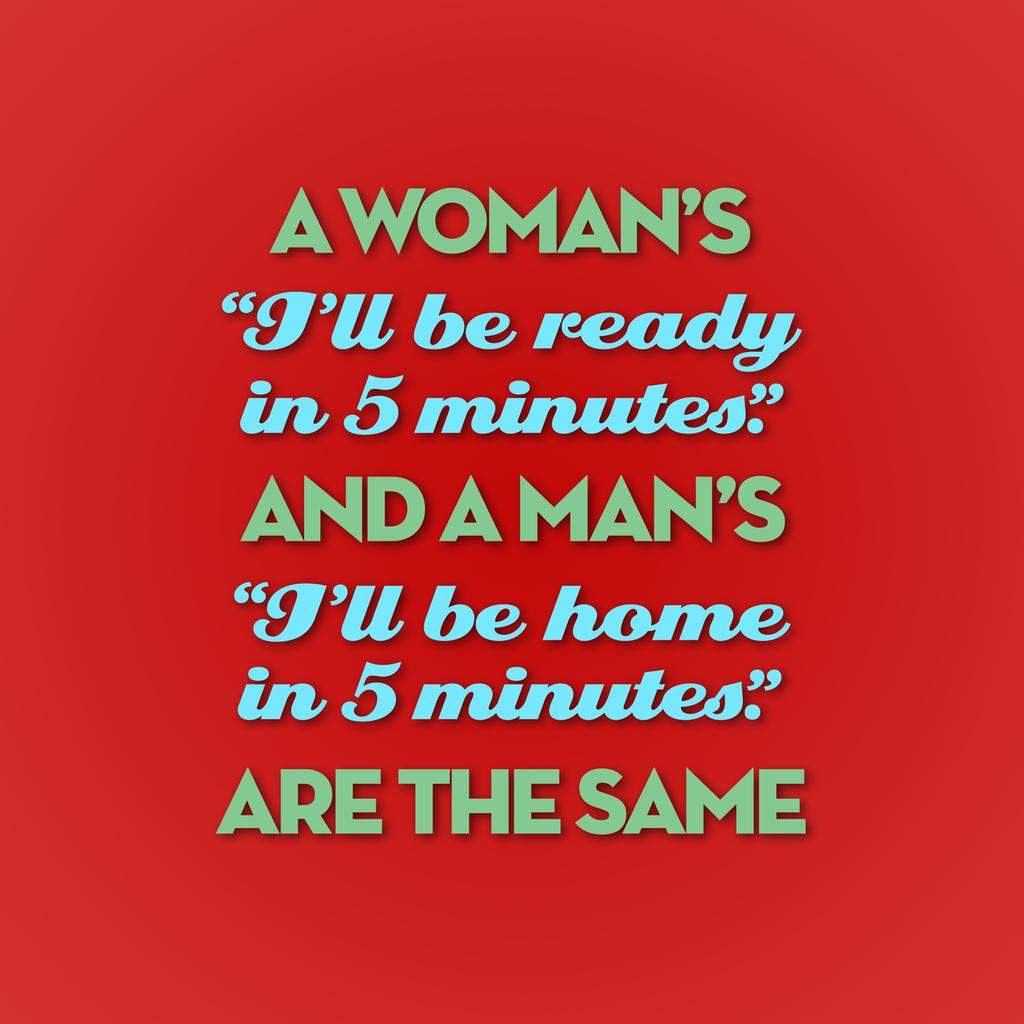Provide a one-sentence caption for the provided image. A vibrant red poster with a humorous saying on it. 